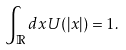<formula> <loc_0><loc_0><loc_500><loc_500>\int _ { \mathbb { R } } d x U ( | x | ) = 1 .</formula> 